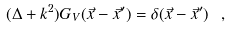<formula> <loc_0><loc_0><loc_500><loc_500>( \Delta + k ^ { 2 } ) G _ { V } ( \vec { x } - \vec { x } ^ { \prime } ) = \delta ( \vec { x } - \vec { x } ^ { \prime } ) \ ,</formula> 